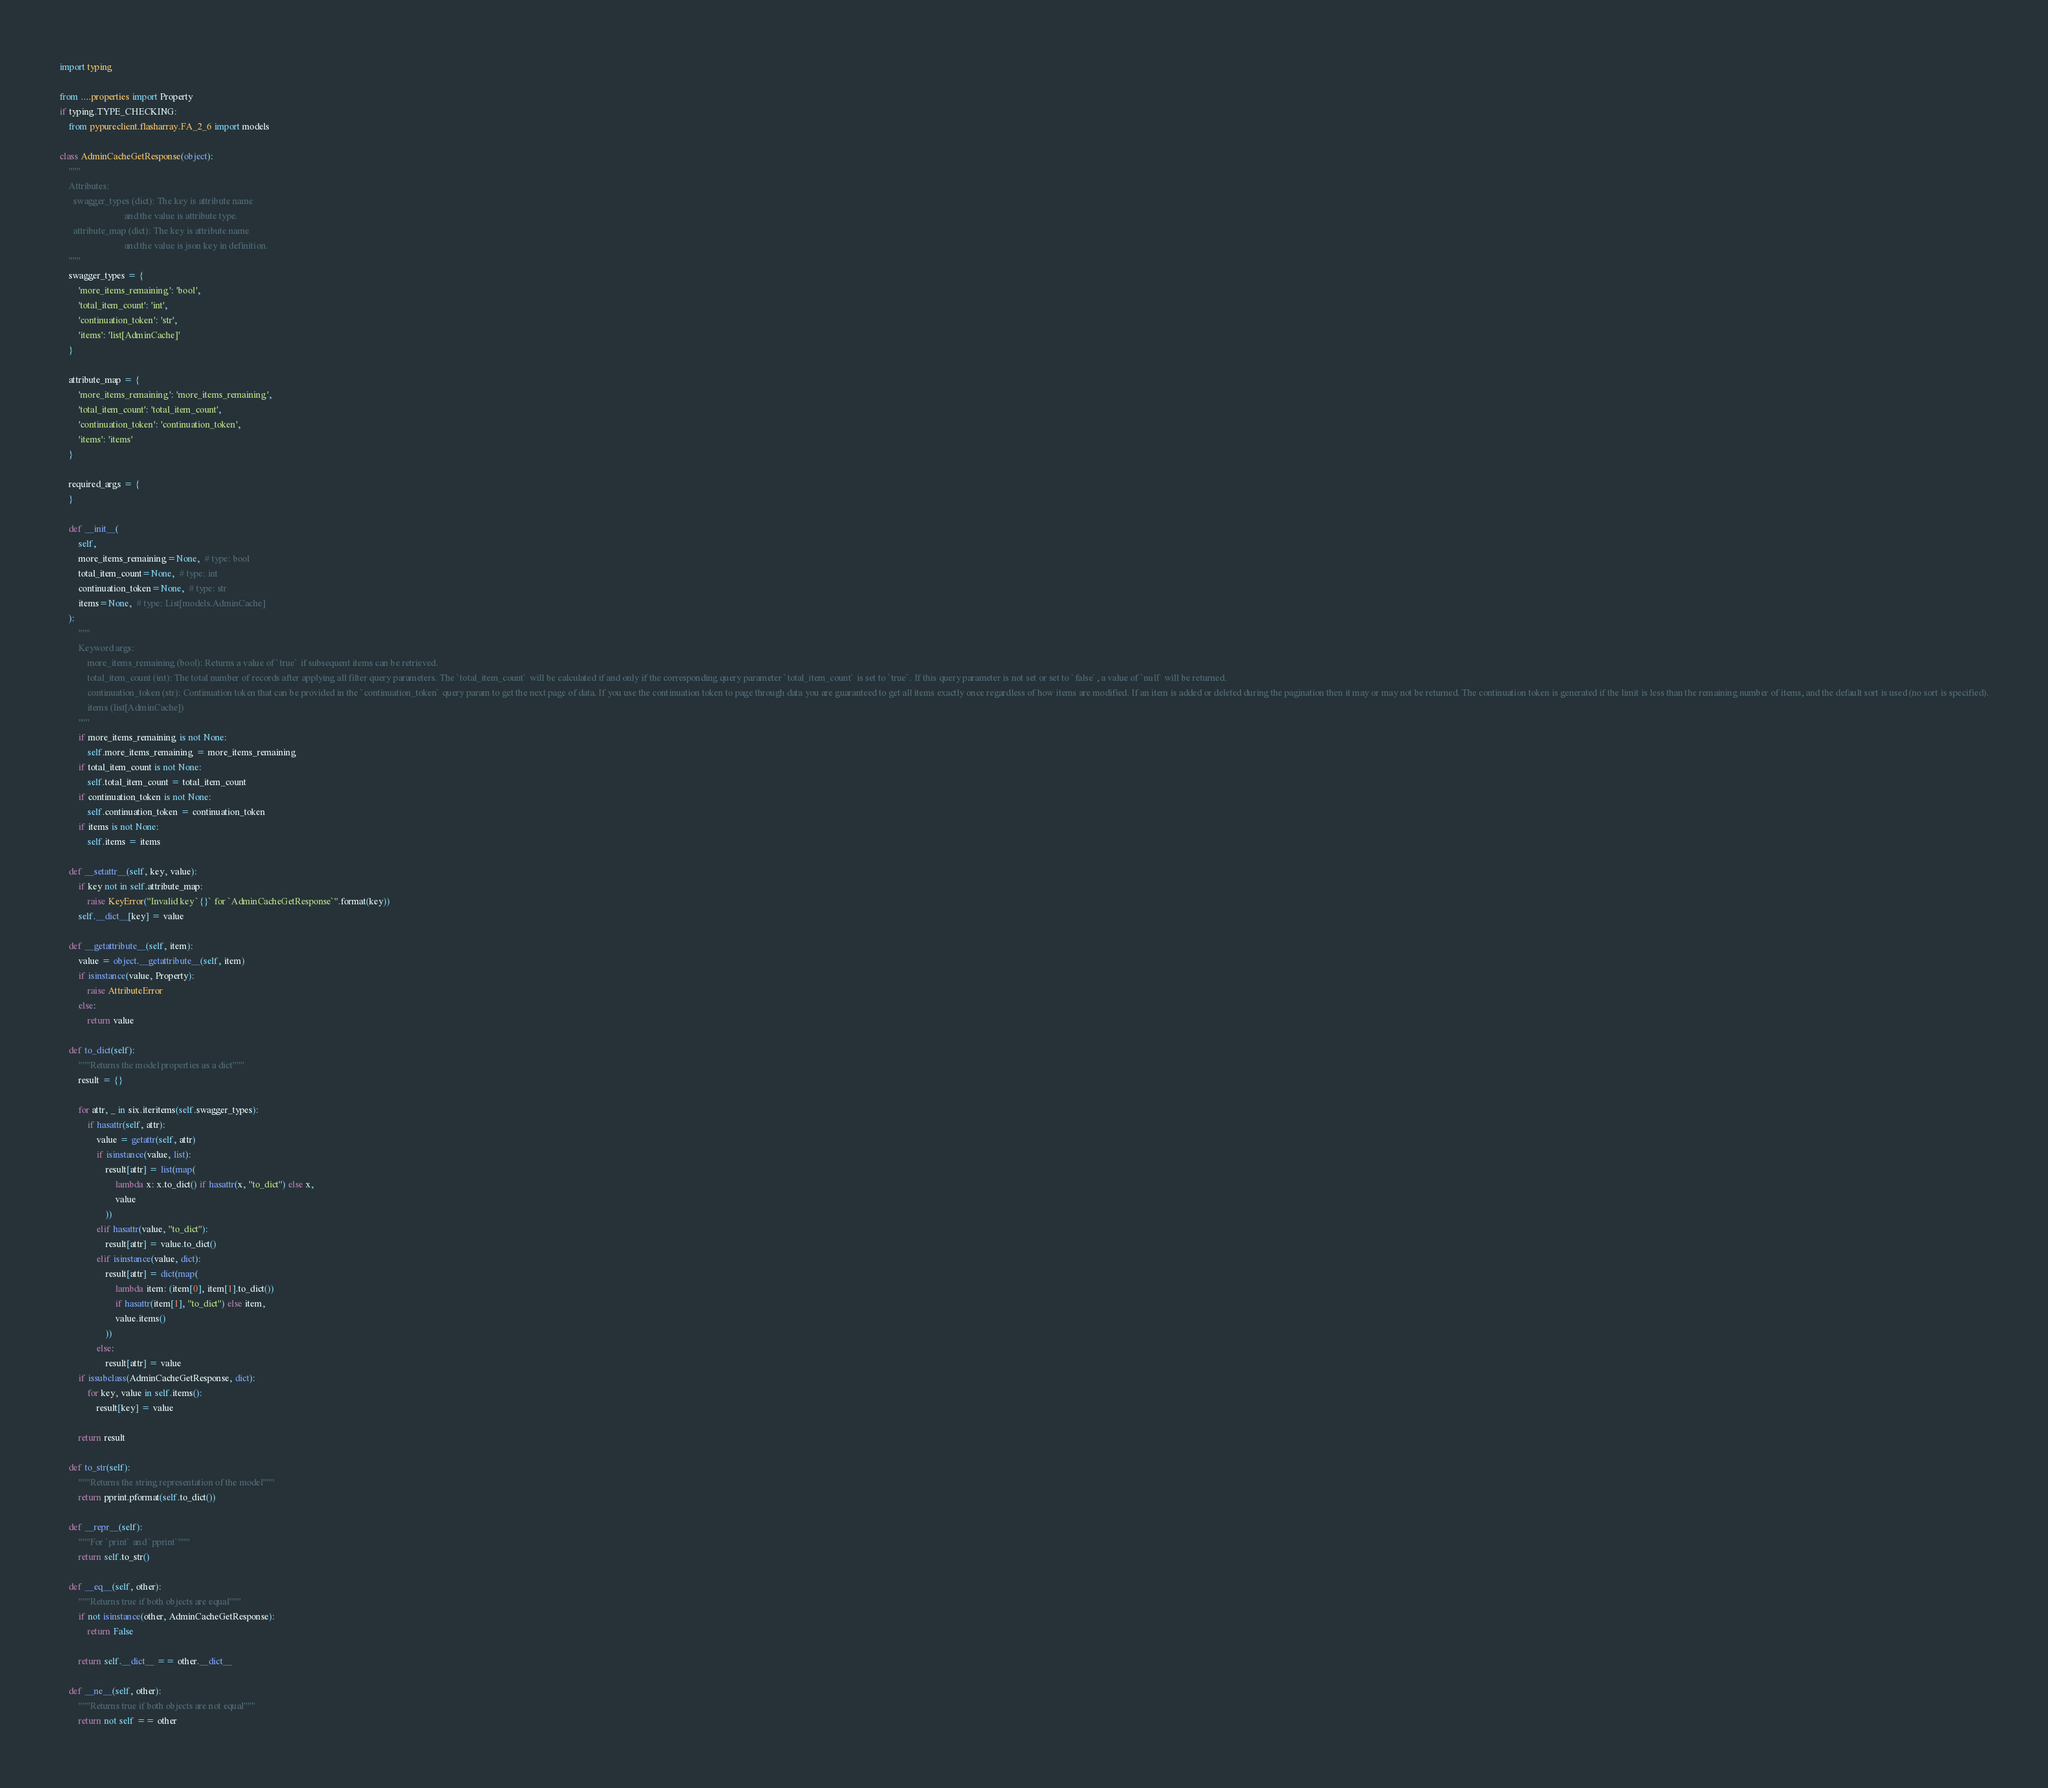<code> <loc_0><loc_0><loc_500><loc_500><_Python_>import typing

from ....properties import Property
if typing.TYPE_CHECKING:
    from pypureclient.flasharray.FA_2_6 import models

class AdminCacheGetResponse(object):
    """
    Attributes:
      swagger_types (dict): The key is attribute name
                            and the value is attribute type.
      attribute_map (dict): The key is attribute name
                            and the value is json key in definition.
    """
    swagger_types = {
        'more_items_remaining': 'bool',
        'total_item_count': 'int',
        'continuation_token': 'str',
        'items': 'list[AdminCache]'
    }

    attribute_map = {
        'more_items_remaining': 'more_items_remaining',
        'total_item_count': 'total_item_count',
        'continuation_token': 'continuation_token',
        'items': 'items'
    }

    required_args = {
    }

    def __init__(
        self,
        more_items_remaining=None,  # type: bool
        total_item_count=None,  # type: int
        continuation_token=None,  # type: str
        items=None,  # type: List[models.AdminCache]
    ):
        """
        Keyword args:
            more_items_remaining (bool): Returns a value of `true` if subsequent items can be retrieved.
            total_item_count (int): The total number of records after applying all filter query parameters. The `total_item_count` will be calculated if and only if the corresponding query parameter `total_item_count` is set to `true`. If this query parameter is not set or set to `false`, a value of `null` will be returned.
            continuation_token (str): Continuation token that can be provided in the `continuation_token` query param to get the next page of data. If you use the continuation token to page through data you are guaranteed to get all items exactly once regardless of how items are modified. If an item is added or deleted during the pagination then it may or may not be returned. The continuation token is generated if the limit is less than the remaining number of items, and the default sort is used (no sort is specified).
            items (list[AdminCache])
        """
        if more_items_remaining is not None:
            self.more_items_remaining = more_items_remaining
        if total_item_count is not None:
            self.total_item_count = total_item_count
        if continuation_token is not None:
            self.continuation_token = continuation_token
        if items is not None:
            self.items = items

    def __setattr__(self, key, value):
        if key not in self.attribute_map:
            raise KeyError("Invalid key `{}` for `AdminCacheGetResponse`".format(key))
        self.__dict__[key] = value

    def __getattribute__(self, item):
        value = object.__getattribute__(self, item)
        if isinstance(value, Property):
            raise AttributeError
        else:
            return value

    def to_dict(self):
        """Returns the model properties as a dict"""
        result = {}

        for attr, _ in six.iteritems(self.swagger_types):
            if hasattr(self, attr):
                value = getattr(self, attr)
                if isinstance(value, list):
                    result[attr] = list(map(
                        lambda x: x.to_dict() if hasattr(x, "to_dict") else x,
                        value
                    ))
                elif hasattr(value, "to_dict"):
                    result[attr] = value.to_dict()
                elif isinstance(value, dict):
                    result[attr] = dict(map(
                        lambda item: (item[0], item[1].to_dict())
                        if hasattr(item[1], "to_dict") else item,
                        value.items()
                    ))
                else:
                    result[attr] = value
        if issubclass(AdminCacheGetResponse, dict):
            for key, value in self.items():
                result[key] = value

        return result

    def to_str(self):
        """Returns the string representation of the model"""
        return pprint.pformat(self.to_dict())

    def __repr__(self):
        """For `print` and `pprint`"""
        return self.to_str()

    def __eq__(self, other):
        """Returns true if both objects are equal"""
        if not isinstance(other, AdminCacheGetResponse):
            return False

        return self.__dict__ == other.__dict__

    def __ne__(self, other):
        """Returns true if both objects are not equal"""
        return not self == other
</code> 